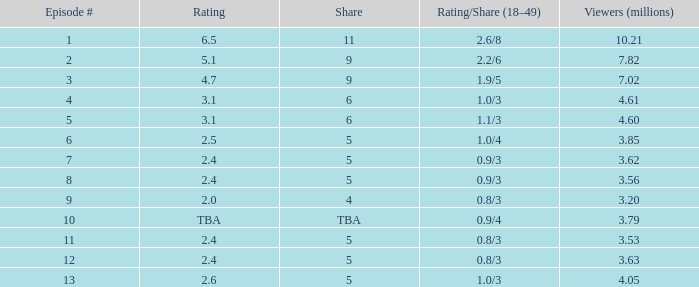What is the lowest numbered episode that had a rating/share of 0.9/4 and more than 3.79 million viewers? None. 